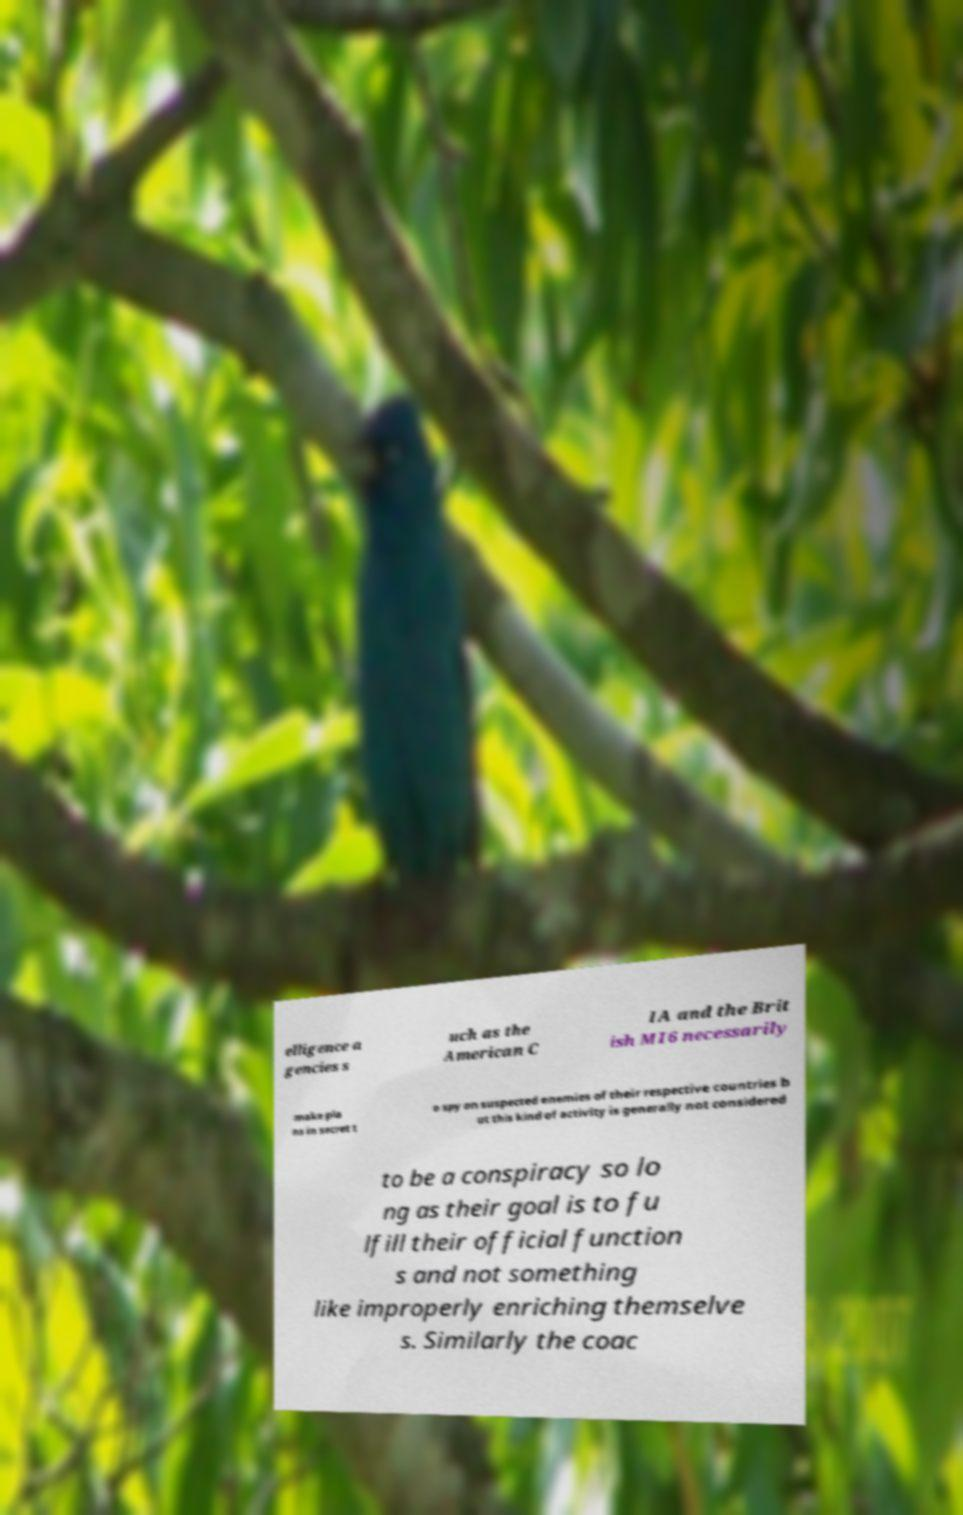Please read and relay the text visible in this image. What does it say? elligence a gencies s uch as the American C IA and the Brit ish MI6 necessarily make pla ns in secret t o spy on suspected enemies of their respective countries b ut this kind of activity is generally not considered to be a conspiracy so lo ng as their goal is to fu lfill their official function s and not something like improperly enriching themselve s. Similarly the coac 